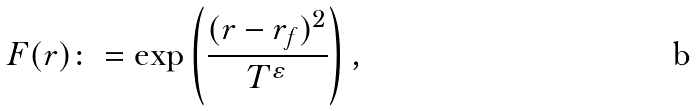Convert formula to latex. <formula><loc_0><loc_0><loc_500><loc_500>F ( r ) \colon = \exp \left ( \frac { ( r - r _ { f } ) ^ { 2 } } { T ^ { \varepsilon } } \right ) ,</formula> 